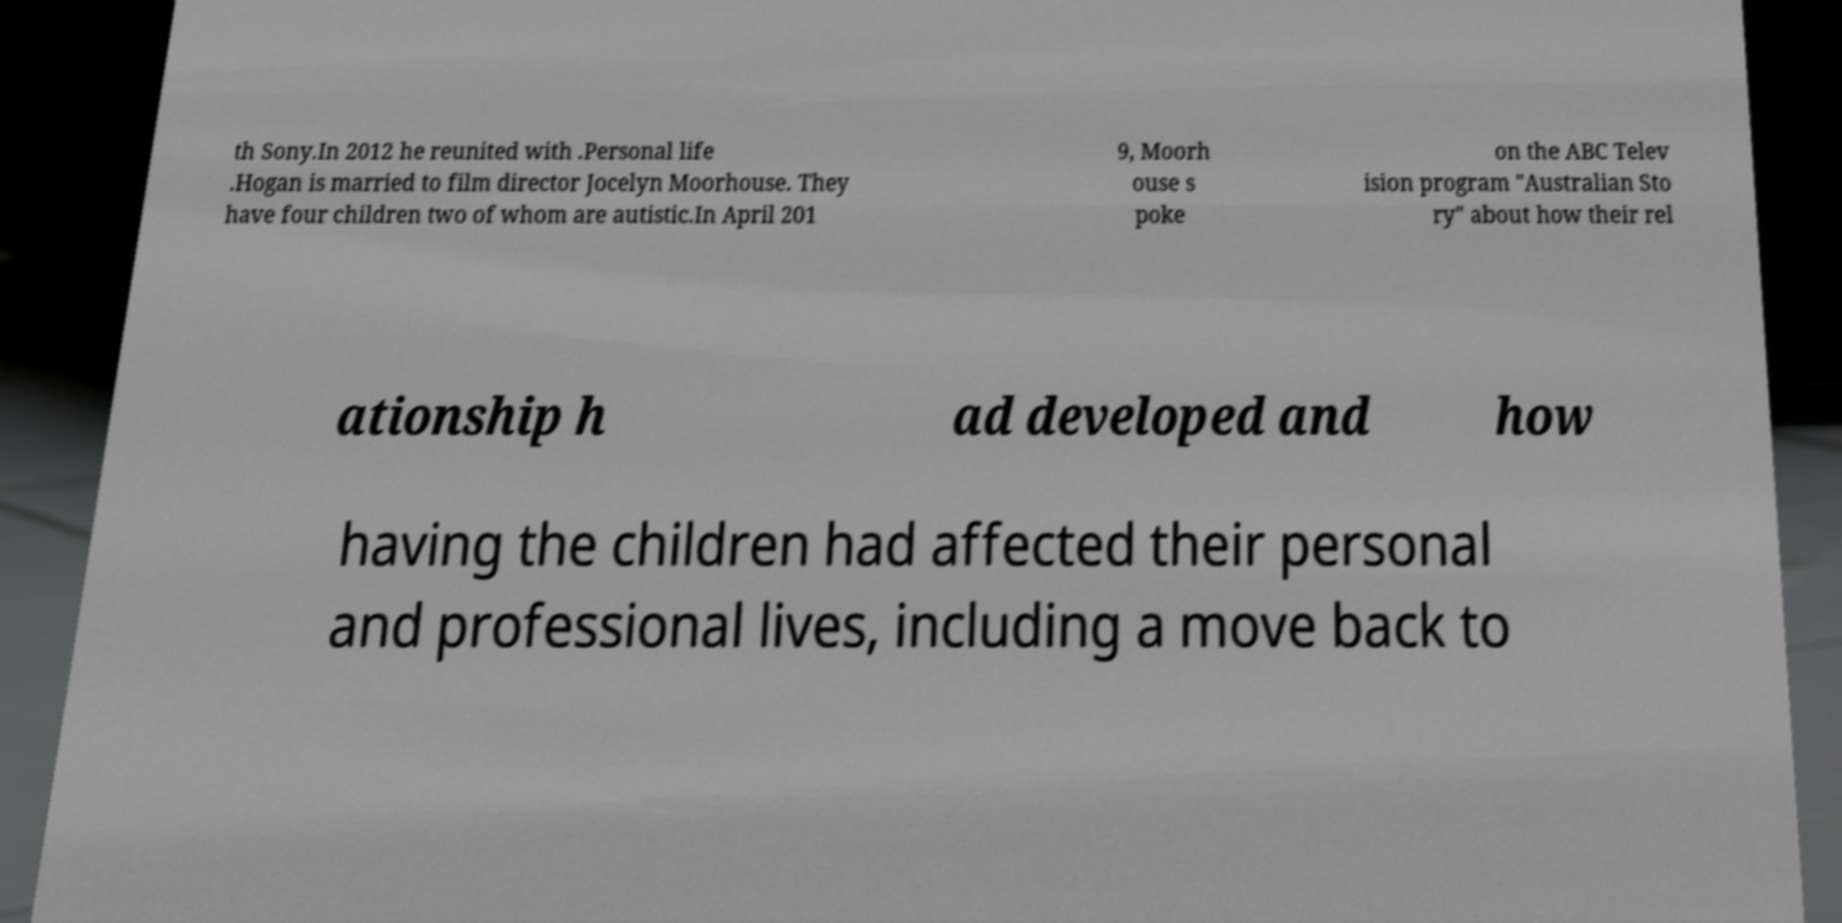Could you extract and type out the text from this image? th Sony.In 2012 he reunited with .Personal life .Hogan is married to film director Jocelyn Moorhouse. They have four children two of whom are autistic.In April 201 9, Moorh ouse s poke on the ABC Telev ision program "Australian Sto ry" about how their rel ationship h ad developed and how having the children had affected their personal and professional lives, including a move back to 